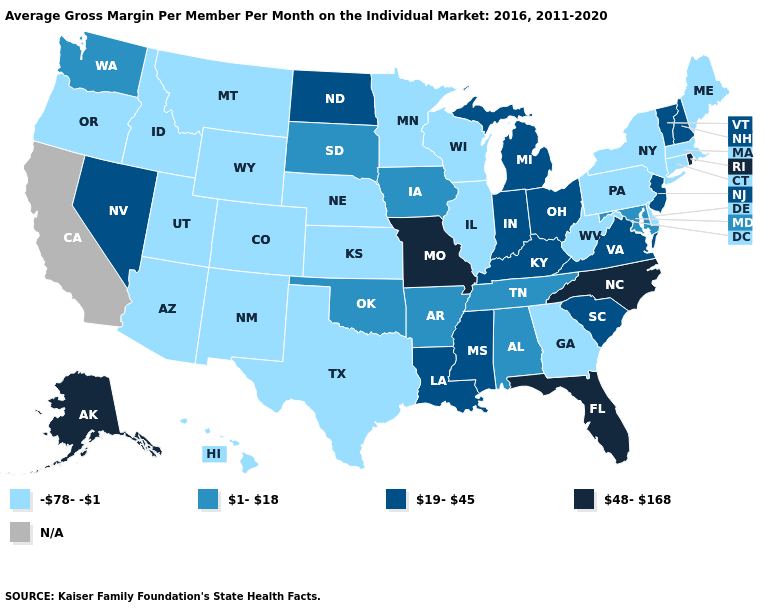Among the states that border Utah , which have the lowest value?
Keep it brief. Arizona, Colorado, Idaho, New Mexico, Wyoming. Name the states that have a value in the range N/A?
Quick response, please. California. What is the value of Arizona?
Quick response, please. -78--1. What is the value of Missouri?
Be succinct. 48-168. Name the states that have a value in the range -78--1?
Write a very short answer. Arizona, Colorado, Connecticut, Delaware, Georgia, Hawaii, Idaho, Illinois, Kansas, Maine, Massachusetts, Minnesota, Montana, Nebraska, New Mexico, New York, Oregon, Pennsylvania, Texas, Utah, West Virginia, Wisconsin, Wyoming. What is the value of Montana?
Give a very brief answer. -78--1. Does the map have missing data?
Short answer required. Yes. What is the lowest value in the Northeast?
Answer briefly. -78--1. Name the states that have a value in the range -78--1?
Quick response, please. Arizona, Colorado, Connecticut, Delaware, Georgia, Hawaii, Idaho, Illinois, Kansas, Maine, Massachusetts, Minnesota, Montana, Nebraska, New Mexico, New York, Oregon, Pennsylvania, Texas, Utah, West Virginia, Wisconsin, Wyoming. Name the states that have a value in the range N/A?
Concise answer only. California. What is the lowest value in states that border South Carolina?
Be succinct. -78--1. Among the states that border Kansas , which have the lowest value?
Concise answer only. Colorado, Nebraska. What is the lowest value in the USA?
Be succinct. -78--1. Does Texas have the lowest value in the South?
Concise answer only. Yes. 